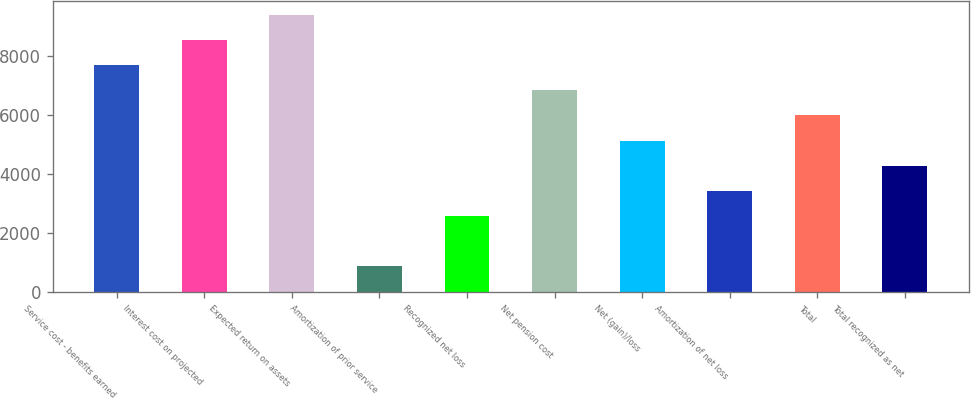Convert chart. <chart><loc_0><loc_0><loc_500><loc_500><bar_chart><fcel>Service cost - benefits earned<fcel>Interest cost on projected<fcel>Expected return on assets<fcel>Amortization of prior service<fcel>Recognized net loss<fcel>Net pension cost<fcel>Net (gain)/loss<fcel>Amortization of net loss<fcel>Total<fcel>Total recognized as net<nl><fcel>7692.1<fcel>8543<fcel>9393.9<fcel>884.9<fcel>2586.7<fcel>6841.2<fcel>5139.4<fcel>3437.6<fcel>5990.3<fcel>4288.5<nl></chart> 